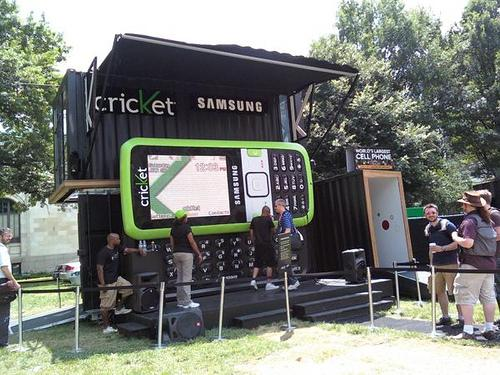Behance network has done most projects on which mobile? Please explain your reasoning. samsung. The network is samsung. 